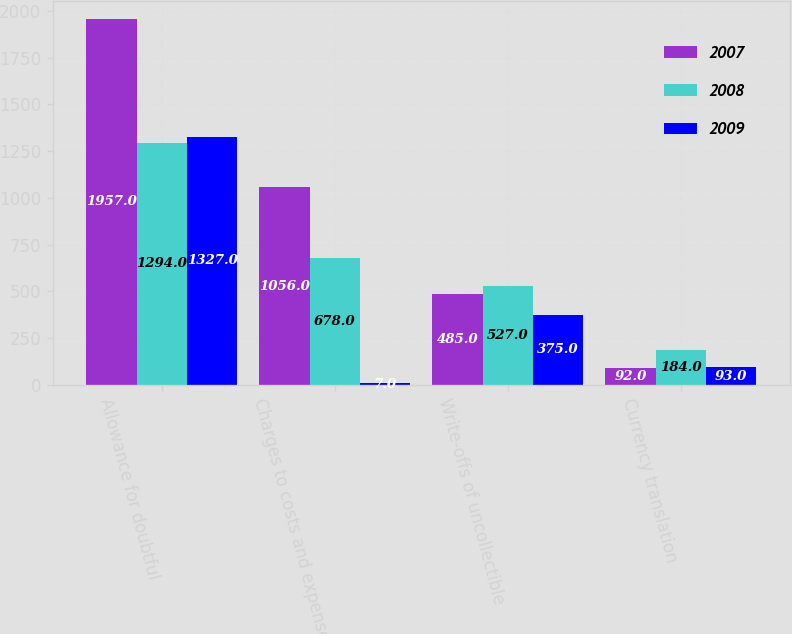Convert chart. <chart><loc_0><loc_0><loc_500><loc_500><stacked_bar_chart><ecel><fcel>Allowance for doubtful<fcel>Charges to costs and expenses<fcel>Write-offs of uncollectible<fcel>Currency translation<nl><fcel>2007<fcel>1957<fcel>1056<fcel>485<fcel>92<nl><fcel>2008<fcel>1294<fcel>678<fcel>527<fcel>184<nl><fcel>2009<fcel>1327<fcel>7<fcel>375<fcel>93<nl></chart> 